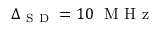Convert formula to latex. <formula><loc_0><loc_0><loc_500><loc_500>\Delta _ { S D } = 1 0 M H z</formula> 